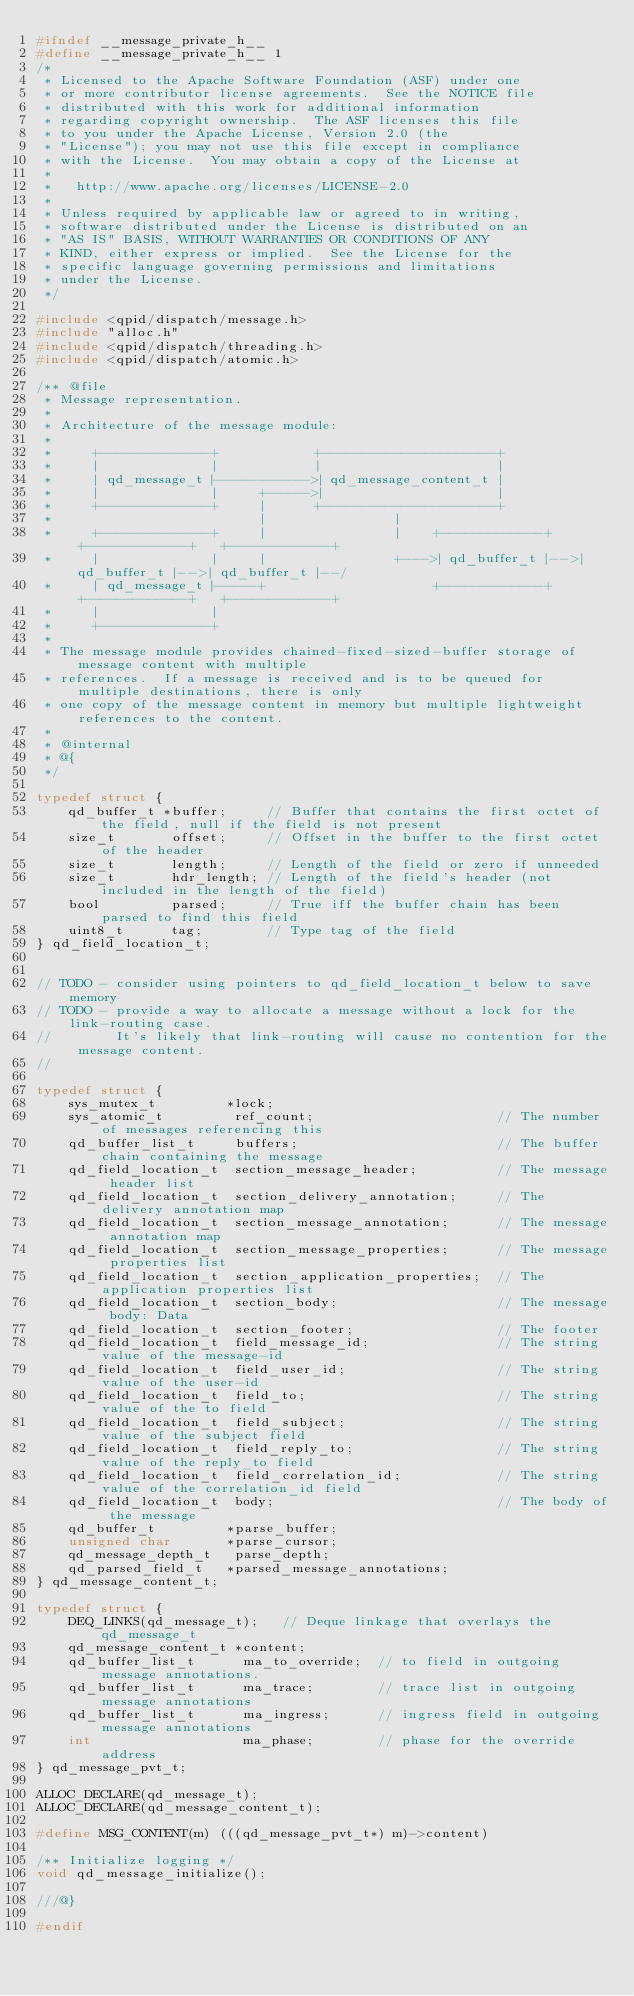<code> <loc_0><loc_0><loc_500><loc_500><_C_>#ifndef __message_private_h__
#define __message_private_h__ 1
/*
 * Licensed to the Apache Software Foundation (ASF) under one
 * or more contributor license agreements.  See the NOTICE file
 * distributed with this work for additional information
 * regarding copyright ownership.  The ASF licenses this file
 * to you under the Apache License, Version 2.0 (the
 * "License"); you may not use this file except in compliance
 * with the License.  You may obtain a copy of the License at
 *
 *   http://www.apache.org/licenses/LICENSE-2.0
 *
 * Unless required by applicable law or agreed to in writing,
 * software distributed under the License is distributed on an
 * "AS IS" BASIS, WITHOUT WARRANTIES OR CONDITIONS OF ANY
 * KIND, either express or implied.  See the License for the
 * specific language governing permissions and limitations
 * under the License.
 */

#include <qpid/dispatch/message.h>
#include "alloc.h"
#include <qpid/dispatch/threading.h>
#include <qpid/dispatch/atomic.h>

/** @file
 * Message representation.
 * 
 * Architecture of the message module:
 *
 *     +--------------+            +----------------------+
 *     |              |            |                      |
 *     | qd_message_t |----------->| qd_message_content_t |
 *     |              |     +----->|                      |
 *     +--------------+     |      +----------------------+
 *                          |                |
 *     +--------------+     |                |    +-------------+   +-------------+   +-------------+
 *     |              |     |                +--->| qd_buffer_t |-->| qd_buffer_t |-->| qd_buffer_t |--/
 *     | qd_message_t |-----+                     +-------------+   +-------------+   +-------------+
 *     |              |
 *     +--------------+
 *
 * The message module provides chained-fixed-sized-buffer storage of message content with multiple
 * references.  If a message is received and is to be queued for multiple destinations, there is only
 * one copy of the message content in memory but multiple lightweight references to the content.
 *
 * @internal
 * @{ 
 */

typedef struct {
    qd_buffer_t *buffer;     // Buffer that contains the first octet of the field, null if the field is not present
    size_t       offset;     // Offset in the buffer to the first octet of the header
    size_t       length;     // Length of the field or zero if unneeded
    size_t       hdr_length; // Length of the field's header (not included in the length of the field)
    bool         parsed;     // True iff the buffer chain has been parsed to find this field
    uint8_t      tag;        // Type tag of the field
} qd_field_location_t;


// TODO - consider using pointers to qd_field_location_t below to save memory
// TODO - provide a way to allocate a message without a lock for the link-routing case.
//        It's likely that link-routing will cause no contention for the message content.
//

typedef struct {
    sys_mutex_t         *lock;
    sys_atomic_t         ref_count;                       // The number of messages referencing this
    qd_buffer_list_t     buffers;                         // The buffer chain containing the message
    qd_field_location_t  section_message_header;          // The message header list
    qd_field_location_t  section_delivery_annotation;     // The delivery annotation map
    qd_field_location_t  section_message_annotation;      // The message annotation map
    qd_field_location_t  section_message_properties;      // The message properties list
    qd_field_location_t  section_application_properties;  // The application properties list
    qd_field_location_t  section_body;                    // The message body: Data
    qd_field_location_t  section_footer;                  // The footer
    qd_field_location_t  field_message_id;                // The string value of the message-id
    qd_field_location_t  field_user_id;                   // The string value of the user-id
    qd_field_location_t  field_to;                        // The string value of the to field
    qd_field_location_t  field_subject;                   // The string value of the subject field
    qd_field_location_t  field_reply_to;                  // The string value of the reply_to field
    qd_field_location_t  field_correlation_id;            // The string value of the correlation_id field
    qd_field_location_t  body;                            // The body of the message
    qd_buffer_t         *parse_buffer;
    unsigned char       *parse_cursor;
    qd_message_depth_t   parse_depth;
    qd_parsed_field_t   *parsed_message_annotations;
} qd_message_content_t;

typedef struct {
    DEQ_LINKS(qd_message_t);   // Deque linkage that overlays the qd_message_t
    qd_message_content_t *content;
    qd_buffer_list_t      ma_to_override;  // to field in outgoing message annotations.
    qd_buffer_list_t      ma_trace;        // trace list in outgoing message annotations
    qd_buffer_list_t      ma_ingress;      // ingress field in outgoing message annotations
    int                   ma_phase;        // phase for the override address
} qd_message_pvt_t;

ALLOC_DECLARE(qd_message_t);
ALLOC_DECLARE(qd_message_content_t);

#define MSG_CONTENT(m) (((qd_message_pvt_t*) m)->content)

/** Initialize logging */
void qd_message_initialize();

///@}

#endif
</code> 